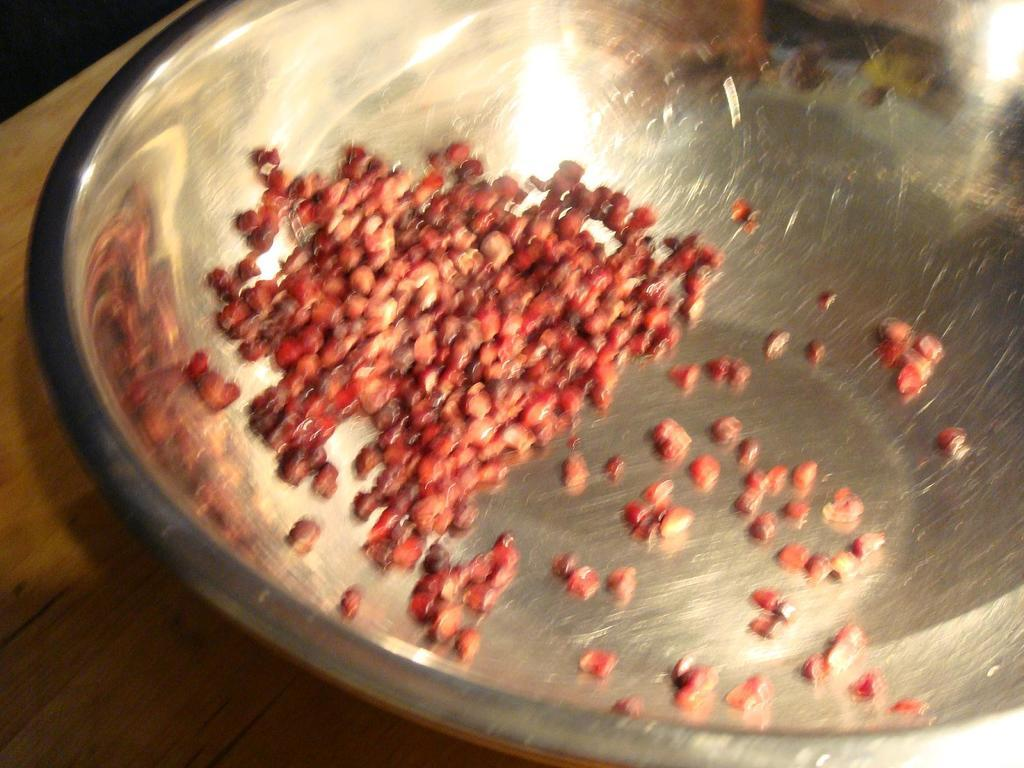What is the main subject of the image? There is a food item in the image. How is the food item presented in the image? The food item is placed in a bowl. How many legs can be seen supporting the hill in the image? There is no hill or legs present in the image. What is the zinc content of the food item in the image? The zinc content of the food item cannot be determined from the image, as it does not provide any information about the ingredients or nutritional value of the food. 